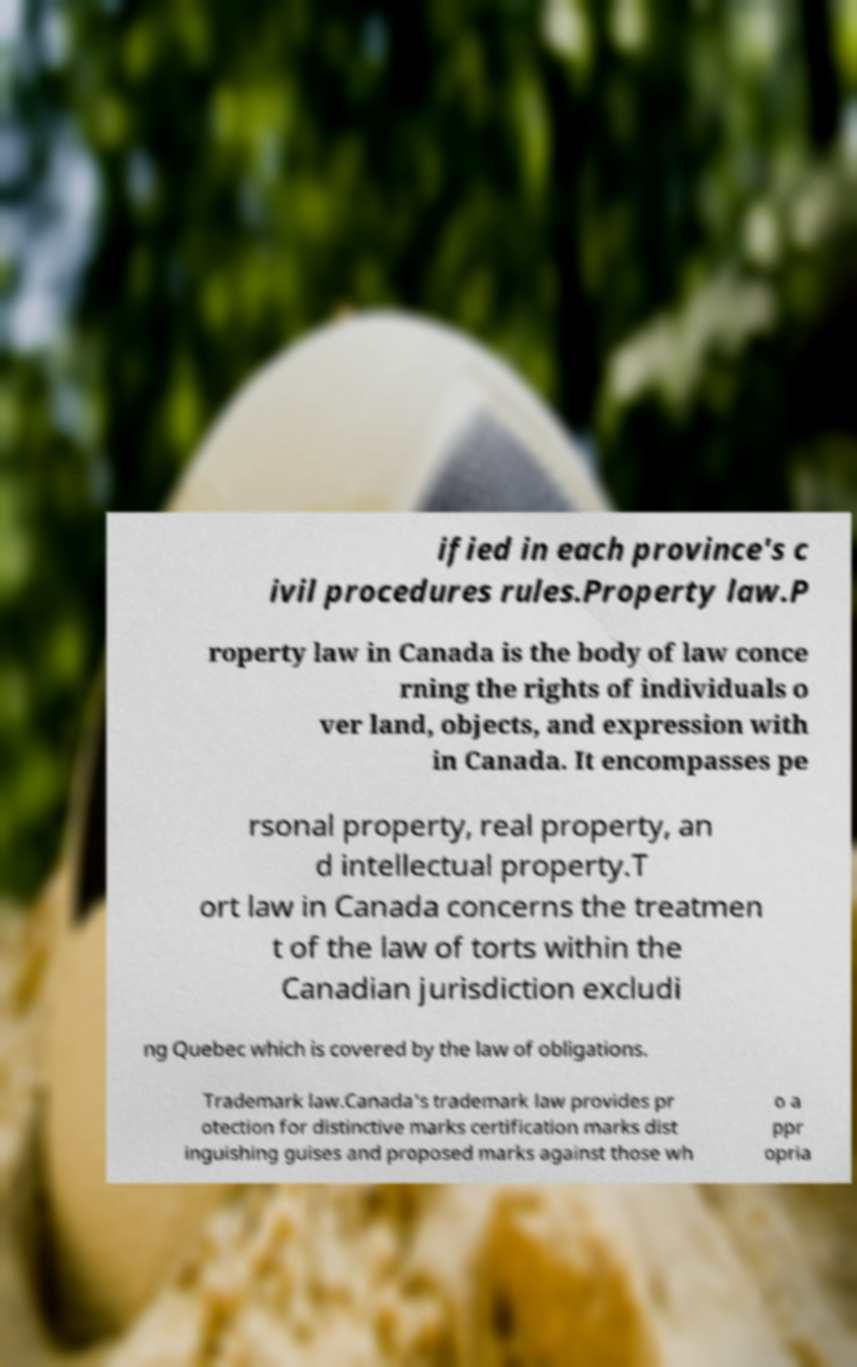Please read and relay the text visible in this image. What does it say? ified in each province's c ivil procedures rules.Property law.P roperty law in Canada is the body of law conce rning the rights of individuals o ver land, objects, and expression with in Canada. It encompasses pe rsonal property, real property, an d intellectual property.T ort law in Canada concerns the treatmen t of the law of torts within the Canadian jurisdiction excludi ng Quebec which is covered by the law of obligations. Trademark law.Canada's trademark law provides pr otection for distinctive marks certification marks dist inguishing guises and proposed marks against those wh o a ppr opria 